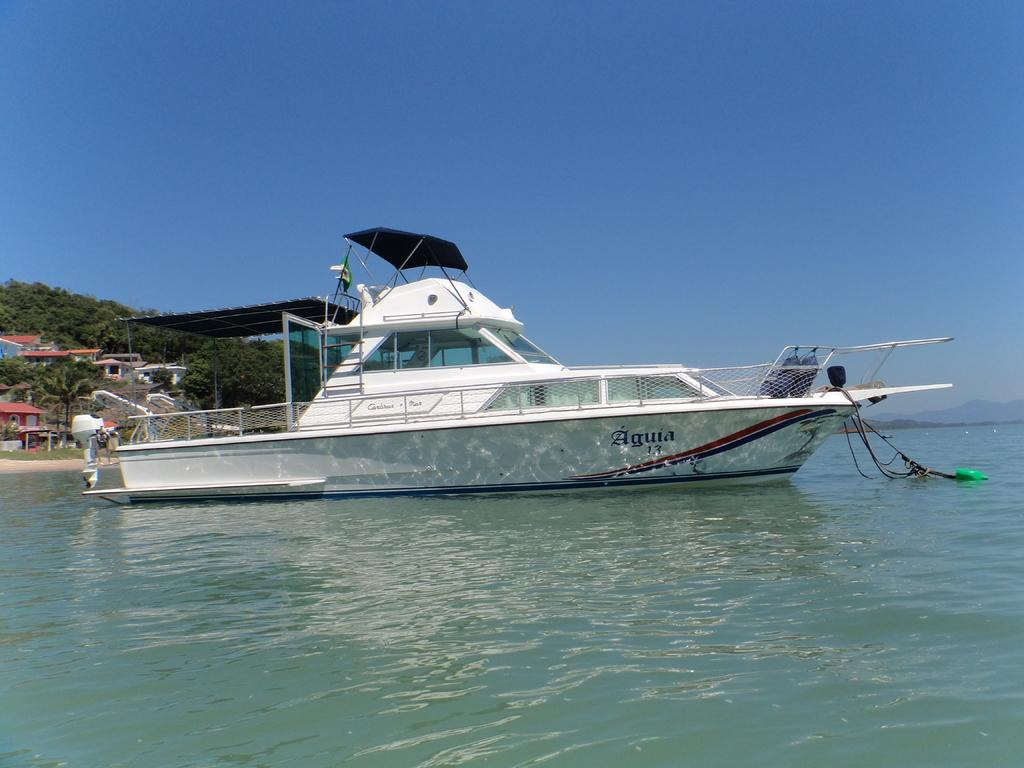What is at the bottom of the image? There is water at the bottom of the image. What is floating on the water? There is a boat in the water. What can be seen in the distance in the image? There are trees and buildings in the background of the image. What is visible at the top of the image? The sky is visible at the top of the image. What type of tools does the carpenter use in the image? There is no carpenter present in the image. How does the farmer contribute to the scene in the image? There is no farmer present in the image. 